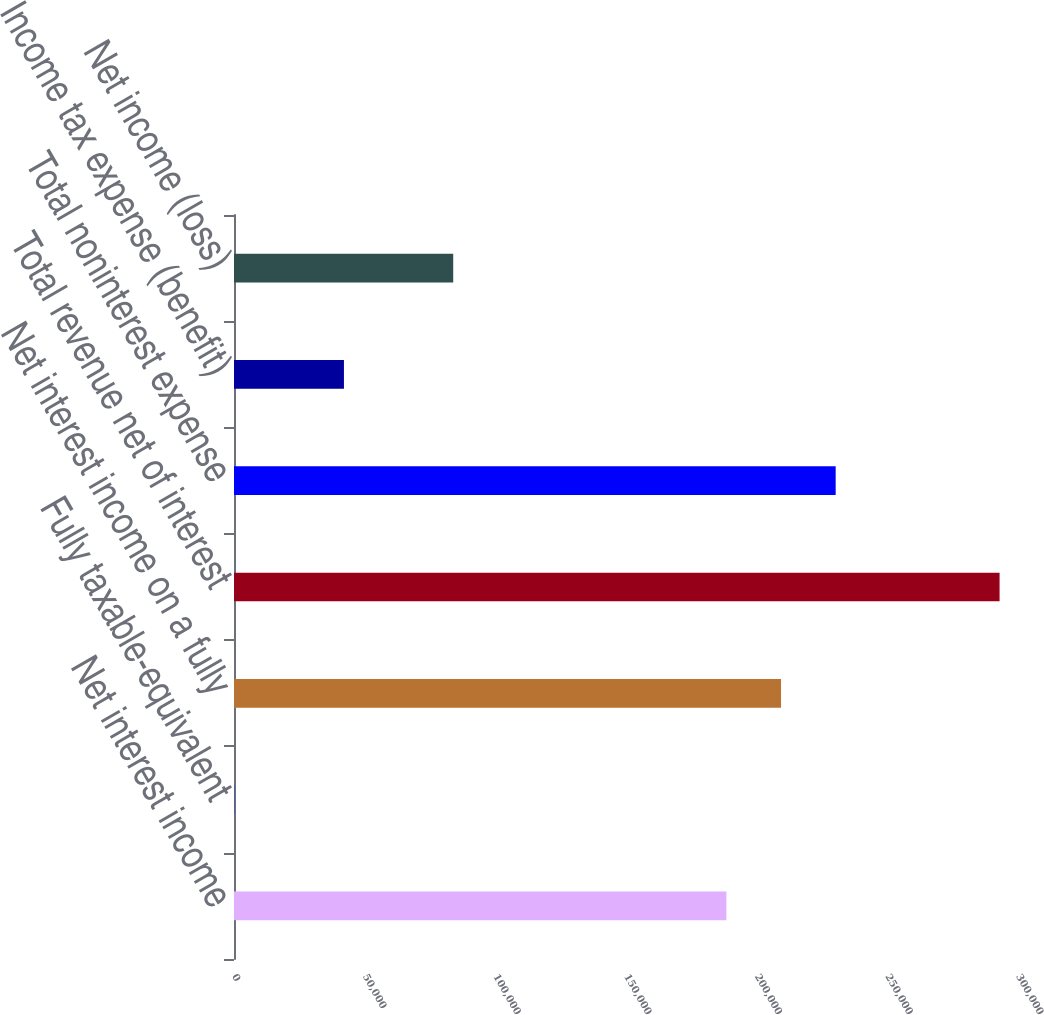Convert chart to OTSL. <chart><loc_0><loc_0><loc_500><loc_500><bar_chart><fcel>Net interest income<fcel>Fully taxable-equivalent<fcel>Net interest income on a fully<fcel>Total revenue net of interest<fcel>Total noninterest expense<fcel>Income tax expense (benefit)<fcel>Net income (loss)<nl><fcel>188417<fcel>258<fcel>209324<fcel>292950<fcel>230231<fcel>42071.2<fcel>83884.4<nl></chart> 